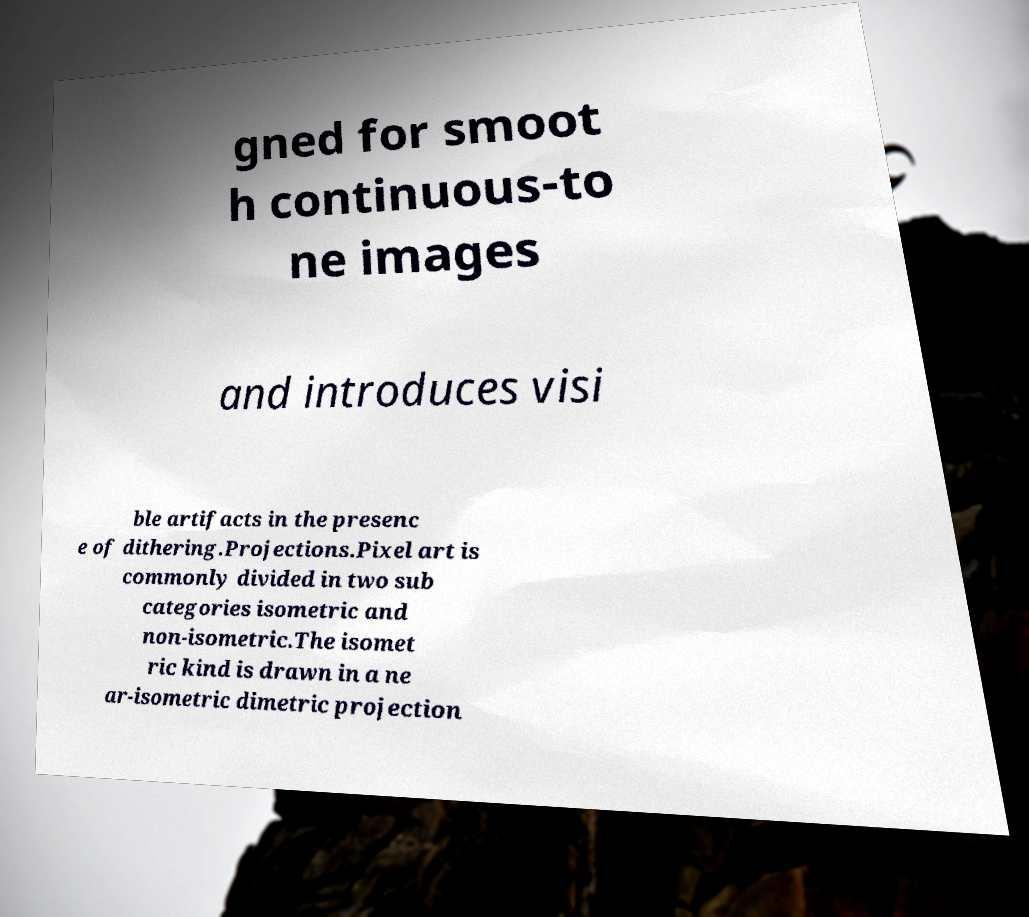I need the written content from this picture converted into text. Can you do that? gned for smoot h continuous-to ne images and introduces visi ble artifacts in the presenc e of dithering.Projections.Pixel art is commonly divided in two sub categories isometric and non-isometric.The isomet ric kind is drawn in a ne ar-isometric dimetric projection 